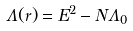Convert formula to latex. <formula><loc_0><loc_0><loc_500><loc_500>\Lambda ( r ) = E ^ { 2 } - N \Lambda _ { 0 }</formula> 